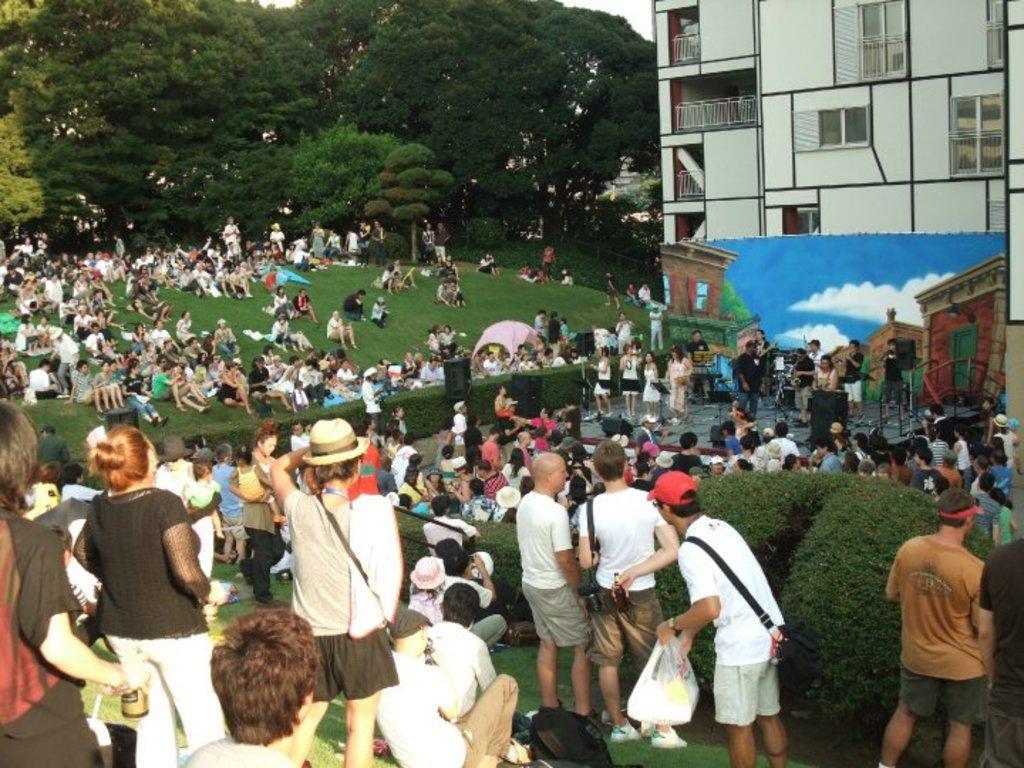Could you give a brief overview of what you see in this image? In this picture we can see some people are standing, some people are sitting on the grass, some people are standing on stage, speakers, plants, banner, trees, building with windows and some objects. 